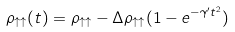<formula> <loc_0><loc_0><loc_500><loc_500>\rho _ { \uparrow \uparrow } ( t ) = \rho _ { \uparrow \uparrow } - \Delta \rho _ { \uparrow \uparrow } ( 1 - e ^ { - \gamma ^ { \prime } t ^ { 2 } } )</formula> 